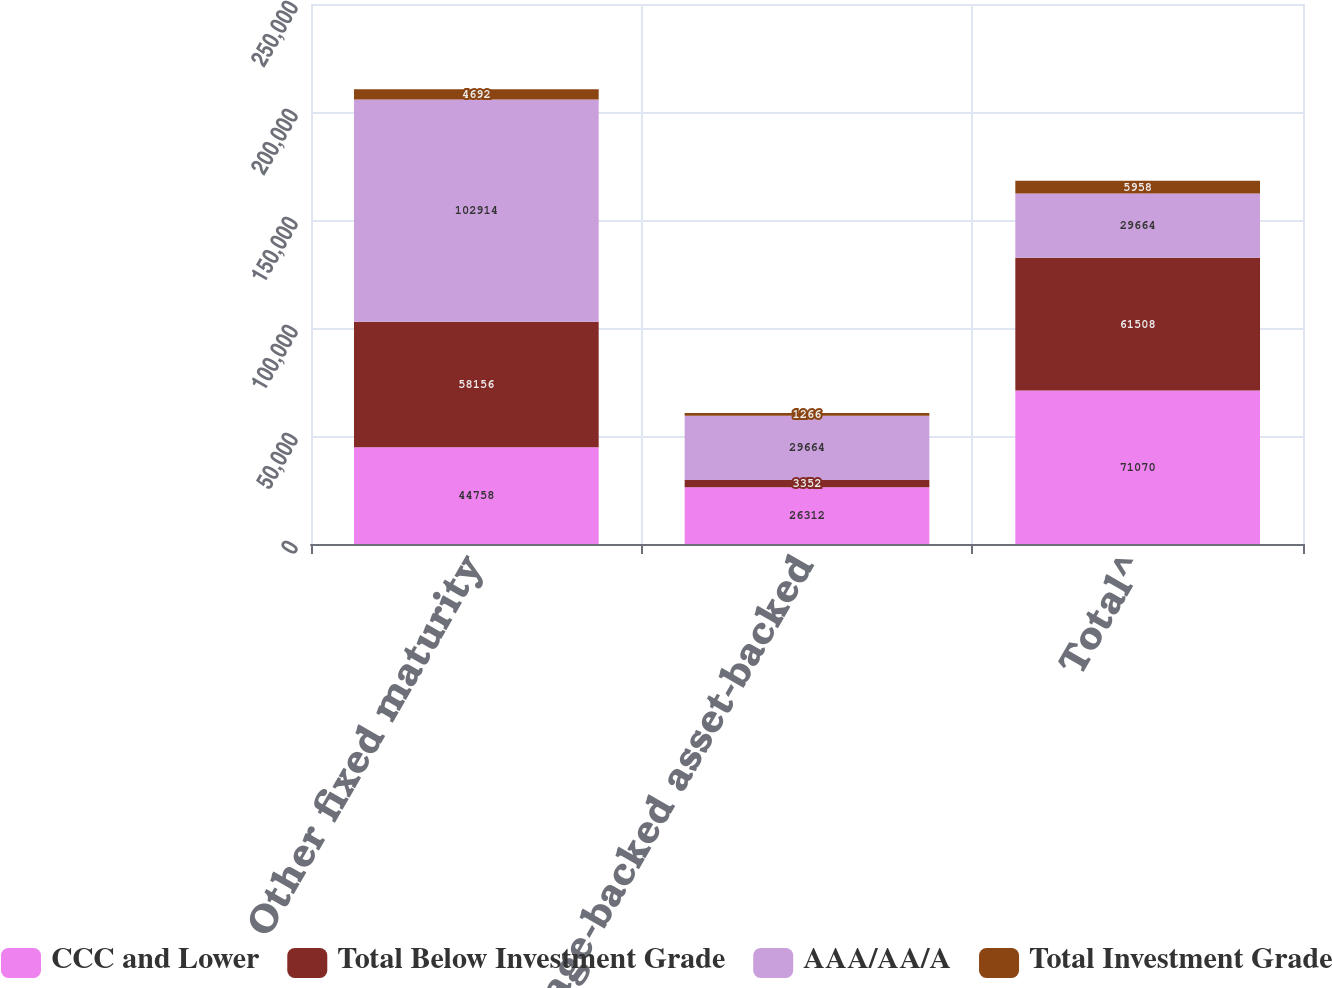Convert chart to OTSL. <chart><loc_0><loc_0><loc_500><loc_500><stacked_bar_chart><ecel><fcel>Other fixed maturity<fcel>Mortgage-backed asset-backed<fcel>Total^<nl><fcel>CCC and Lower<fcel>44758<fcel>26312<fcel>71070<nl><fcel>Total Below Investment Grade<fcel>58156<fcel>3352<fcel>61508<nl><fcel>AAA/AA/A<fcel>102914<fcel>29664<fcel>29664<nl><fcel>Total Investment Grade<fcel>4692<fcel>1266<fcel>5958<nl></chart> 